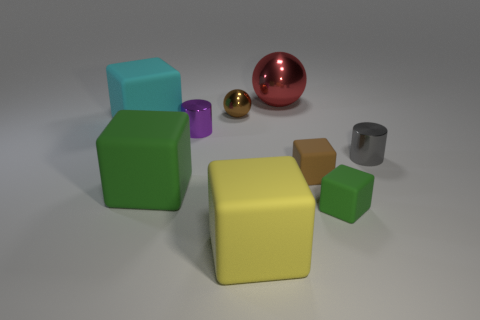Do the big cyan thing and the small green cube have the same material?
Make the answer very short. Yes. There is a thing that is the same color as the tiny sphere; what size is it?
Offer a terse response. Small. Is there a thing of the same color as the tiny sphere?
Offer a very short reply. Yes. What size is the brown block that is the same material as the cyan cube?
Provide a short and direct response. Small. What is the shape of the green rubber object that is to the right of the green object that is left of the object that is behind the small ball?
Make the answer very short. Cube. What is the size of the brown thing that is the same shape as the cyan thing?
Keep it short and to the point. Small. There is a matte thing that is on the right side of the purple cylinder and left of the big red object; what size is it?
Make the answer very short. Large. The tiny object that is the same color as the small ball is what shape?
Offer a terse response. Cube. The tiny sphere is what color?
Provide a succinct answer. Brown. There is a green cube that is to the right of the large shiny ball; what is its size?
Keep it short and to the point. Small. 